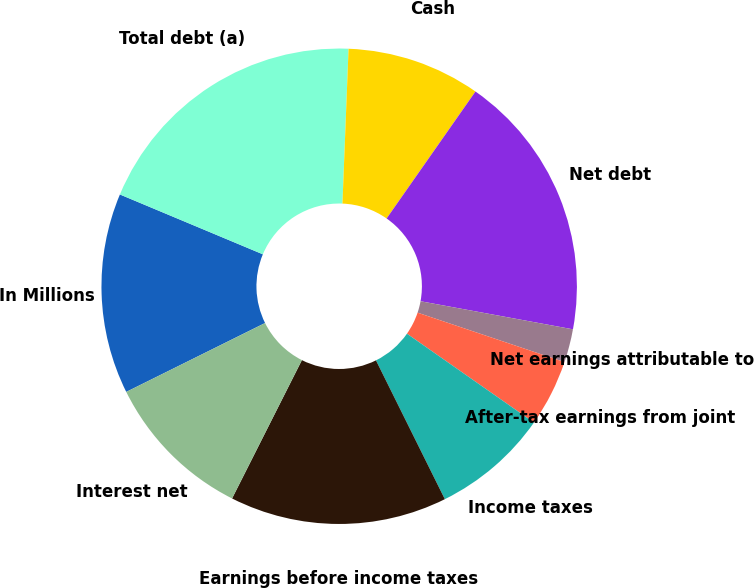Convert chart to OTSL. <chart><loc_0><loc_0><loc_500><loc_500><pie_chart><fcel>In Millions<fcel>Total debt (a)<fcel>Cash<fcel>Net debt<fcel>Net earnings attributable to<fcel>After-tax earnings from joint<fcel>Income taxes<fcel>Earnings before income taxes<fcel>Interest net<nl><fcel>13.64%<fcel>19.32%<fcel>9.09%<fcel>18.18%<fcel>2.27%<fcel>4.55%<fcel>7.95%<fcel>14.77%<fcel>10.23%<nl></chart> 